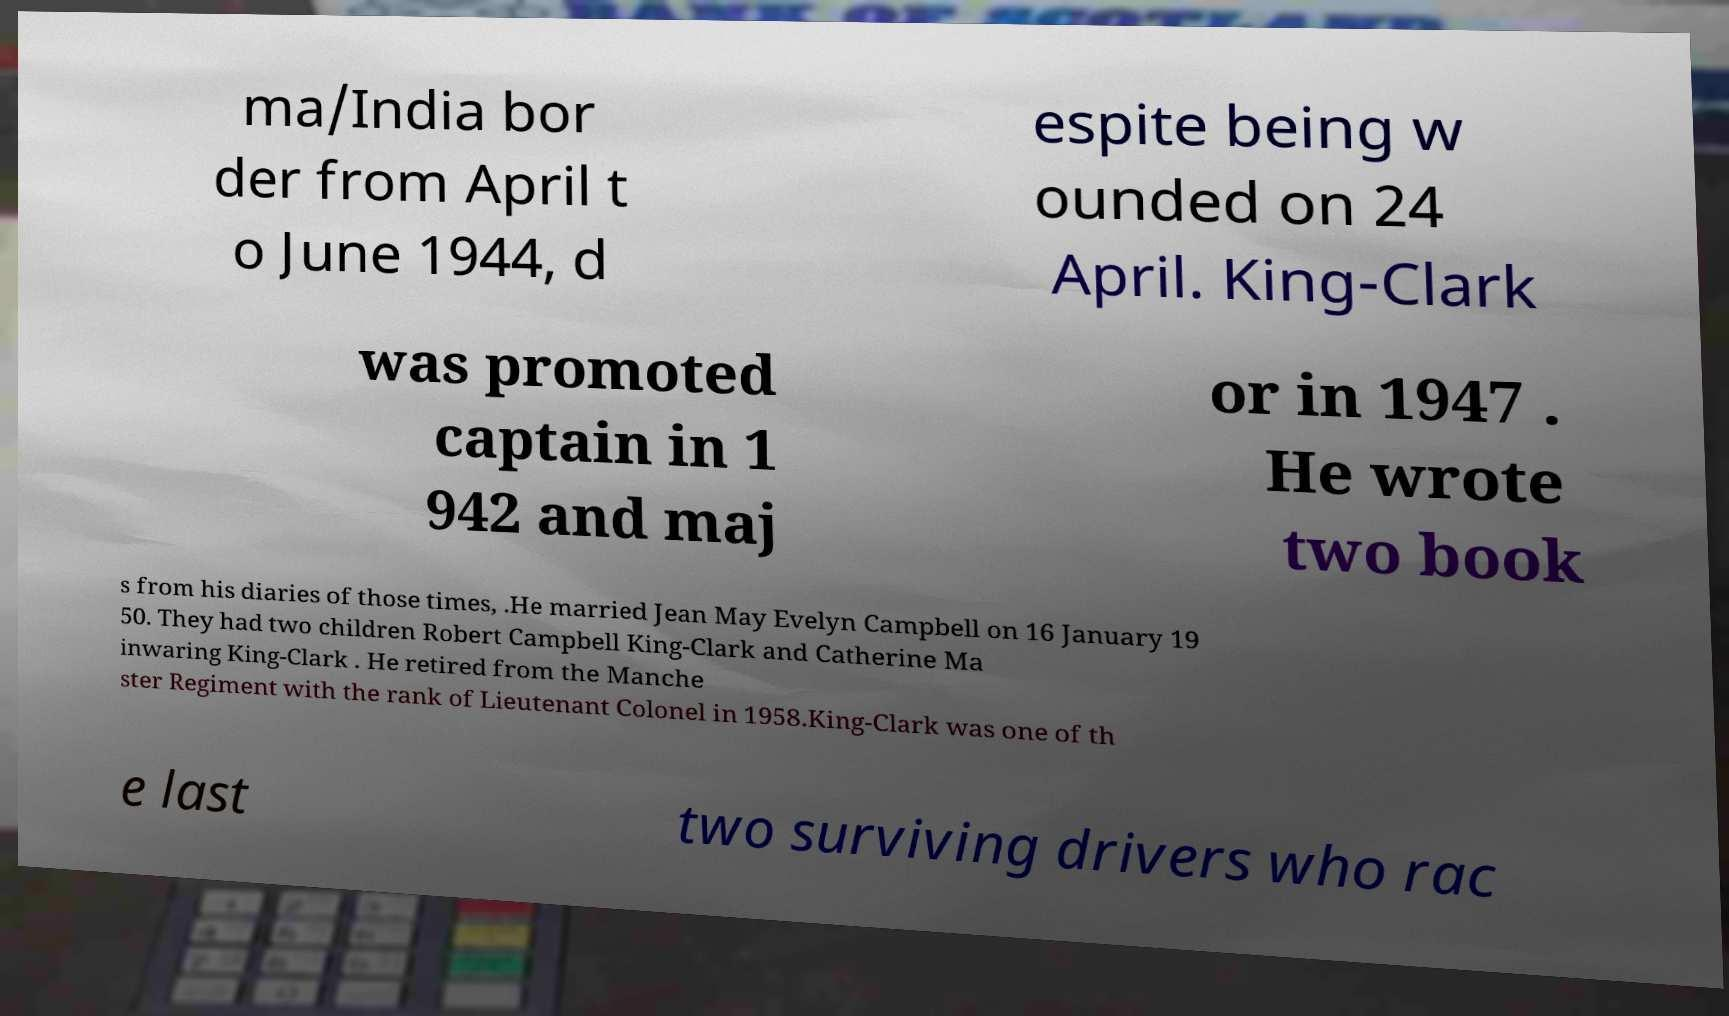Could you assist in decoding the text presented in this image and type it out clearly? ma/India bor der from April t o June 1944, d espite being w ounded on 24 April. King-Clark was promoted captain in 1 942 and maj or in 1947 . He wrote two book s from his diaries of those times, .He married Jean May Evelyn Campbell on 16 January 19 50. They had two children Robert Campbell King-Clark and Catherine Ma inwaring King-Clark . He retired from the Manche ster Regiment with the rank of Lieutenant Colonel in 1958.King-Clark was one of th e last two surviving drivers who rac 